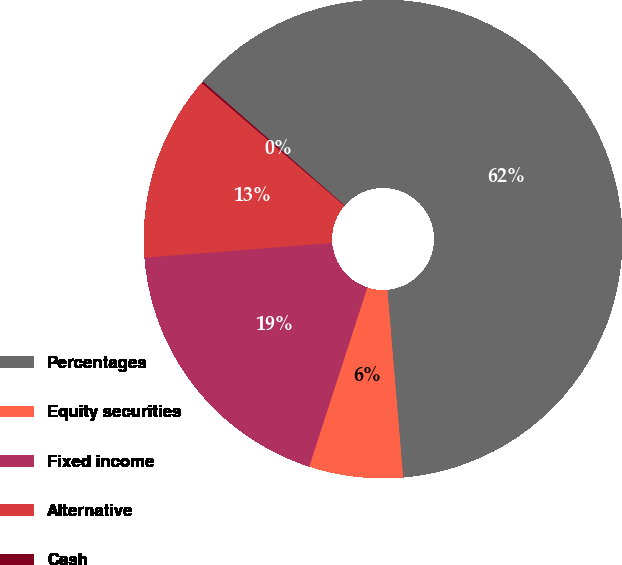<chart> <loc_0><loc_0><loc_500><loc_500><pie_chart><fcel>Percentages<fcel>Equity securities<fcel>Fixed income<fcel>Alternative<fcel>Cash<nl><fcel>62.24%<fcel>6.33%<fcel>18.76%<fcel>12.55%<fcel>0.12%<nl></chart> 